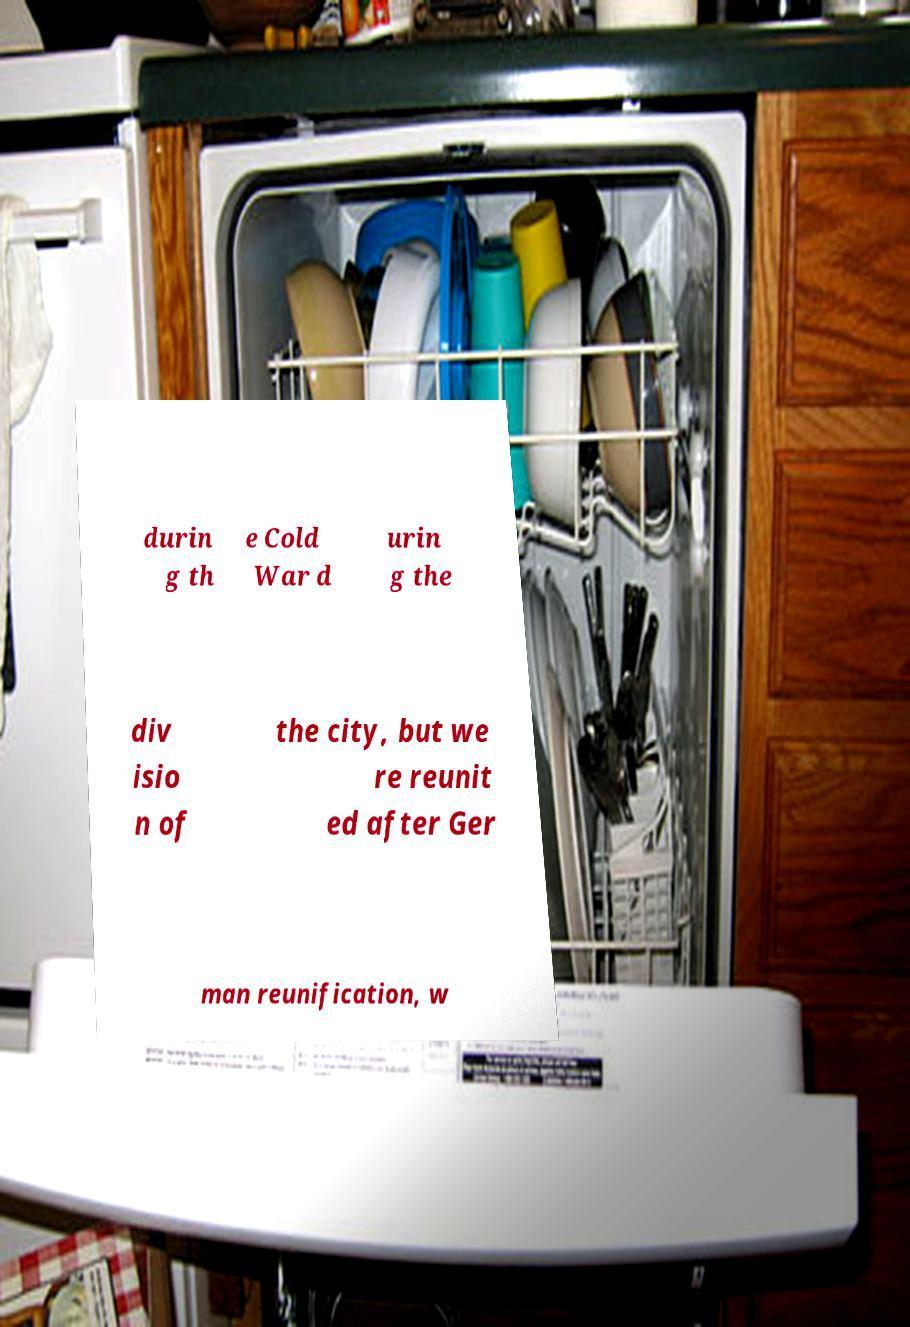I need the written content from this picture converted into text. Can you do that? durin g th e Cold War d urin g the div isio n of the city, but we re reunit ed after Ger man reunification, w 